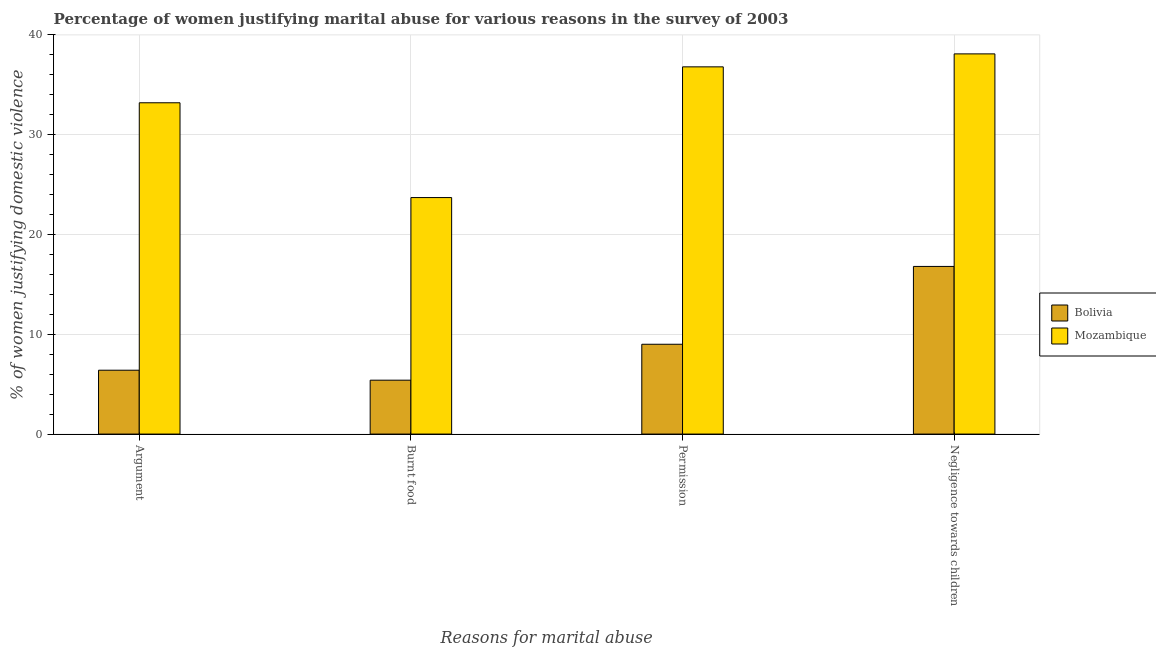How many different coloured bars are there?
Your answer should be very brief. 2. How many groups of bars are there?
Give a very brief answer. 4. How many bars are there on the 2nd tick from the left?
Offer a very short reply. 2. What is the label of the 4th group of bars from the left?
Provide a short and direct response. Negligence towards children. What is the percentage of women justifying abuse for burning food in Bolivia?
Make the answer very short. 5.4. Across all countries, what is the maximum percentage of women justifying abuse for burning food?
Provide a short and direct response. 23.7. Across all countries, what is the minimum percentage of women justifying abuse for going without permission?
Provide a succinct answer. 9. In which country was the percentage of women justifying abuse for showing negligence towards children maximum?
Your answer should be very brief. Mozambique. What is the total percentage of women justifying abuse for going without permission in the graph?
Provide a succinct answer. 45.8. What is the difference between the percentage of women justifying abuse for showing negligence towards children in Bolivia and that in Mozambique?
Offer a terse response. -21.3. What is the difference between the percentage of women justifying abuse for burning food in Bolivia and the percentage of women justifying abuse for going without permission in Mozambique?
Your answer should be compact. -31.4. What is the average percentage of women justifying abuse in the case of an argument per country?
Offer a terse response. 19.8. What is the difference between the percentage of women justifying abuse in the case of an argument and percentage of women justifying abuse for showing negligence towards children in Bolivia?
Offer a very short reply. -10.4. In how many countries, is the percentage of women justifying abuse for burning food greater than 32 %?
Keep it short and to the point. 0. What is the ratio of the percentage of women justifying abuse for burning food in Bolivia to that in Mozambique?
Offer a very short reply. 0.23. Is the percentage of women justifying abuse for showing negligence towards children in Bolivia less than that in Mozambique?
Provide a short and direct response. Yes. Is the difference between the percentage of women justifying abuse in the case of an argument in Bolivia and Mozambique greater than the difference between the percentage of women justifying abuse for showing negligence towards children in Bolivia and Mozambique?
Provide a succinct answer. No. What is the difference between the highest and the second highest percentage of women justifying abuse for showing negligence towards children?
Your answer should be compact. 21.3. What is the difference between the highest and the lowest percentage of women justifying abuse in the case of an argument?
Keep it short and to the point. 26.8. Is the sum of the percentage of women justifying abuse for burning food in Bolivia and Mozambique greater than the maximum percentage of women justifying abuse for going without permission across all countries?
Your response must be concise. No. Is it the case that in every country, the sum of the percentage of women justifying abuse for showing negligence towards children and percentage of women justifying abuse for going without permission is greater than the sum of percentage of women justifying abuse for burning food and percentage of women justifying abuse in the case of an argument?
Your answer should be very brief. No. What does the 1st bar from the left in Permission represents?
Provide a succinct answer. Bolivia. What does the 2nd bar from the right in Burnt food represents?
Ensure brevity in your answer.  Bolivia. Is it the case that in every country, the sum of the percentage of women justifying abuse in the case of an argument and percentage of women justifying abuse for burning food is greater than the percentage of women justifying abuse for going without permission?
Provide a short and direct response. Yes. How many bars are there?
Your answer should be very brief. 8. Are all the bars in the graph horizontal?
Offer a terse response. No. What is the difference between two consecutive major ticks on the Y-axis?
Keep it short and to the point. 10. Does the graph contain any zero values?
Keep it short and to the point. No. How many legend labels are there?
Offer a very short reply. 2. How are the legend labels stacked?
Your answer should be very brief. Vertical. What is the title of the graph?
Your response must be concise. Percentage of women justifying marital abuse for various reasons in the survey of 2003. What is the label or title of the X-axis?
Your answer should be very brief. Reasons for marital abuse. What is the label or title of the Y-axis?
Keep it short and to the point. % of women justifying domestic violence. What is the % of women justifying domestic violence of Bolivia in Argument?
Keep it short and to the point. 6.4. What is the % of women justifying domestic violence in Mozambique in Argument?
Provide a short and direct response. 33.2. What is the % of women justifying domestic violence in Bolivia in Burnt food?
Your answer should be very brief. 5.4. What is the % of women justifying domestic violence in Mozambique in Burnt food?
Offer a very short reply. 23.7. What is the % of women justifying domestic violence in Bolivia in Permission?
Provide a short and direct response. 9. What is the % of women justifying domestic violence of Mozambique in Permission?
Give a very brief answer. 36.8. What is the % of women justifying domestic violence in Mozambique in Negligence towards children?
Provide a short and direct response. 38.1. Across all Reasons for marital abuse, what is the maximum % of women justifying domestic violence of Mozambique?
Keep it short and to the point. 38.1. Across all Reasons for marital abuse, what is the minimum % of women justifying domestic violence of Bolivia?
Offer a very short reply. 5.4. Across all Reasons for marital abuse, what is the minimum % of women justifying domestic violence of Mozambique?
Give a very brief answer. 23.7. What is the total % of women justifying domestic violence of Bolivia in the graph?
Make the answer very short. 37.6. What is the total % of women justifying domestic violence in Mozambique in the graph?
Provide a short and direct response. 131.8. What is the difference between the % of women justifying domestic violence in Bolivia in Argument and that in Burnt food?
Provide a short and direct response. 1. What is the difference between the % of women justifying domestic violence of Bolivia in Argument and that in Permission?
Provide a short and direct response. -2.6. What is the difference between the % of women justifying domestic violence in Mozambique in Argument and that in Permission?
Provide a short and direct response. -3.6. What is the difference between the % of women justifying domestic violence of Bolivia in Argument and that in Negligence towards children?
Your answer should be very brief. -10.4. What is the difference between the % of women justifying domestic violence in Mozambique in Argument and that in Negligence towards children?
Keep it short and to the point. -4.9. What is the difference between the % of women justifying domestic violence of Bolivia in Burnt food and that in Negligence towards children?
Make the answer very short. -11.4. What is the difference between the % of women justifying domestic violence of Mozambique in Burnt food and that in Negligence towards children?
Provide a succinct answer. -14.4. What is the difference between the % of women justifying domestic violence of Bolivia in Argument and the % of women justifying domestic violence of Mozambique in Burnt food?
Offer a very short reply. -17.3. What is the difference between the % of women justifying domestic violence of Bolivia in Argument and the % of women justifying domestic violence of Mozambique in Permission?
Provide a short and direct response. -30.4. What is the difference between the % of women justifying domestic violence in Bolivia in Argument and the % of women justifying domestic violence in Mozambique in Negligence towards children?
Ensure brevity in your answer.  -31.7. What is the difference between the % of women justifying domestic violence of Bolivia in Burnt food and the % of women justifying domestic violence of Mozambique in Permission?
Provide a succinct answer. -31.4. What is the difference between the % of women justifying domestic violence of Bolivia in Burnt food and the % of women justifying domestic violence of Mozambique in Negligence towards children?
Give a very brief answer. -32.7. What is the difference between the % of women justifying domestic violence of Bolivia in Permission and the % of women justifying domestic violence of Mozambique in Negligence towards children?
Make the answer very short. -29.1. What is the average % of women justifying domestic violence of Bolivia per Reasons for marital abuse?
Give a very brief answer. 9.4. What is the average % of women justifying domestic violence of Mozambique per Reasons for marital abuse?
Make the answer very short. 32.95. What is the difference between the % of women justifying domestic violence in Bolivia and % of women justifying domestic violence in Mozambique in Argument?
Provide a succinct answer. -26.8. What is the difference between the % of women justifying domestic violence of Bolivia and % of women justifying domestic violence of Mozambique in Burnt food?
Give a very brief answer. -18.3. What is the difference between the % of women justifying domestic violence of Bolivia and % of women justifying domestic violence of Mozambique in Permission?
Your answer should be compact. -27.8. What is the difference between the % of women justifying domestic violence of Bolivia and % of women justifying domestic violence of Mozambique in Negligence towards children?
Ensure brevity in your answer.  -21.3. What is the ratio of the % of women justifying domestic violence of Bolivia in Argument to that in Burnt food?
Give a very brief answer. 1.19. What is the ratio of the % of women justifying domestic violence of Mozambique in Argument to that in Burnt food?
Your answer should be very brief. 1.4. What is the ratio of the % of women justifying domestic violence of Bolivia in Argument to that in Permission?
Offer a terse response. 0.71. What is the ratio of the % of women justifying domestic violence of Mozambique in Argument to that in Permission?
Your answer should be compact. 0.9. What is the ratio of the % of women justifying domestic violence of Bolivia in Argument to that in Negligence towards children?
Offer a terse response. 0.38. What is the ratio of the % of women justifying domestic violence of Mozambique in Argument to that in Negligence towards children?
Offer a very short reply. 0.87. What is the ratio of the % of women justifying domestic violence in Bolivia in Burnt food to that in Permission?
Offer a very short reply. 0.6. What is the ratio of the % of women justifying domestic violence of Mozambique in Burnt food to that in Permission?
Make the answer very short. 0.64. What is the ratio of the % of women justifying domestic violence in Bolivia in Burnt food to that in Negligence towards children?
Keep it short and to the point. 0.32. What is the ratio of the % of women justifying domestic violence of Mozambique in Burnt food to that in Negligence towards children?
Give a very brief answer. 0.62. What is the ratio of the % of women justifying domestic violence of Bolivia in Permission to that in Negligence towards children?
Ensure brevity in your answer.  0.54. What is the ratio of the % of women justifying domestic violence in Mozambique in Permission to that in Negligence towards children?
Your response must be concise. 0.97. What is the difference between the highest and the second highest % of women justifying domestic violence of Bolivia?
Give a very brief answer. 7.8. What is the difference between the highest and the second highest % of women justifying domestic violence of Mozambique?
Make the answer very short. 1.3. 